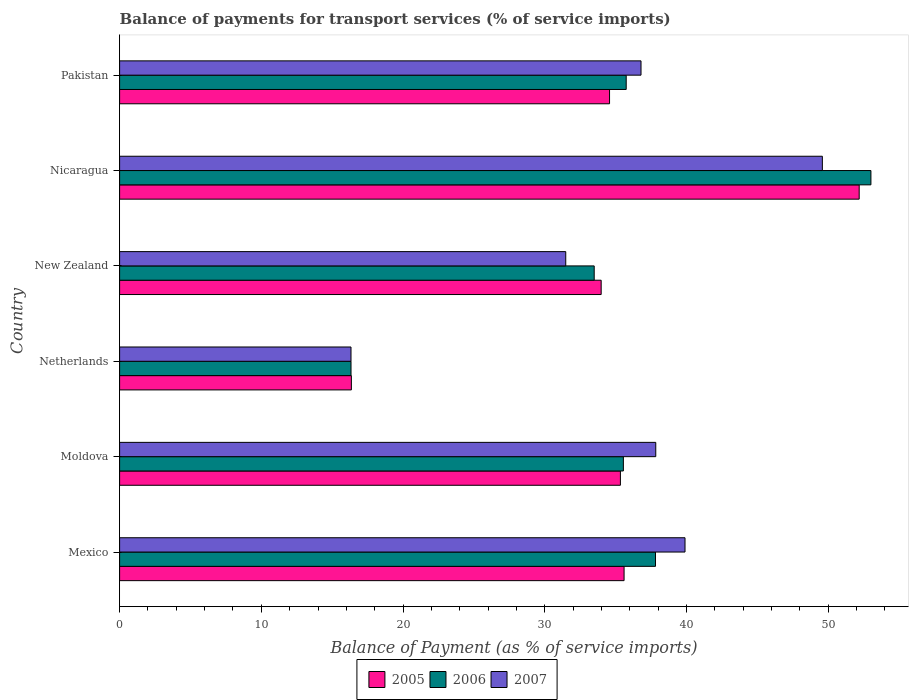Are the number of bars per tick equal to the number of legend labels?
Your answer should be compact. Yes. Are the number of bars on each tick of the Y-axis equal?
Make the answer very short. Yes. How many bars are there on the 4th tick from the top?
Offer a terse response. 3. How many bars are there on the 6th tick from the bottom?
Offer a very short reply. 3. What is the balance of payments for transport services in 2005 in Netherlands?
Your response must be concise. 16.35. Across all countries, what is the maximum balance of payments for transport services in 2005?
Offer a very short reply. 52.19. Across all countries, what is the minimum balance of payments for transport services in 2007?
Your response must be concise. 16.33. In which country was the balance of payments for transport services in 2007 maximum?
Offer a terse response. Nicaragua. In which country was the balance of payments for transport services in 2007 minimum?
Make the answer very short. Netherlands. What is the total balance of payments for transport services in 2005 in the graph?
Offer a very short reply. 208.03. What is the difference between the balance of payments for transport services in 2006 in Nicaragua and that in Pakistan?
Give a very brief answer. 17.27. What is the difference between the balance of payments for transport services in 2005 in New Zealand and the balance of payments for transport services in 2007 in Mexico?
Keep it short and to the point. -5.92. What is the average balance of payments for transport services in 2005 per country?
Give a very brief answer. 34.67. What is the difference between the balance of payments for transport services in 2006 and balance of payments for transport services in 2005 in New Zealand?
Make the answer very short. -0.49. In how many countries, is the balance of payments for transport services in 2005 greater than 20 %?
Provide a short and direct response. 5. What is the ratio of the balance of payments for transport services in 2007 in Nicaragua to that in Pakistan?
Your response must be concise. 1.35. Is the difference between the balance of payments for transport services in 2006 in Moldova and New Zealand greater than the difference between the balance of payments for transport services in 2005 in Moldova and New Zealand?
Make the answer very short. Yes. What is the difference between the highest and the second highest balance of payments for transport services in 2007?
Give a very brief answer. 9.69. What is the difference between the highest and the lowest balance of payments for transport services in 2007?
Ensure brevity in your answer.  33.26. Is the sum of the balance of payments for transport services in 2006 in Mexico and New Zealand greater than the maximum balance of payments for transport services in 2005 across all countries?
Your answer should be very brief. Yes. What does the 3rd bar from the bottom in Netherlands represents?
Keep it short and to the point. 2007. What is the difference between two consecutive major ticks on the X-axis?
Offer a terse response. 10. Are the values on the major ticks of X-axis written in scientific E-notation?
Your answer should be very brief. No. Does the graph contain any zero values?
Your answer should be very brief. No. Does the graph contain grids?
Provide a succinct answer. No. Where does the legend appear in the graph?
Provide a short and direct response. Bottom center. How many legend labels are there?
Give a very brief answer. 3. What is the title of the graph?
Give a very brief answer. Balance of payments for transport services (% of service imports). What is the label or title of the X-axis?
Give a very brief answer. Balance of Payment (as % of service imports). What is the label or title of the Y-axis?
Ensure brevity in your answer.  Country. What is the Balance of Payment (as % of service imports) of 2005 in Mexico?
Make the answer very short. 35.6. What is the Balance of Payment (as % of service imports) of 2006 in Mexico?
Offer a very short reply. 37.81. What is the Balance of Payment (as % of service imports) of 2007 in Mexico?
Offer a terse response. 39.9. What is the Balance of Payment (as % of service imports) of 2005 in Moldova?
Provide a succinct answer. 35.34. What is the Balance of Payment (as % of service imports) in 2006 in Moldova?
Keep it short and to the point. 35.55. What is the Balance of Payment (as % of service imports) of 2007 in Moldova?
Provide a succinct answer. 37.83. What is the Balance of Payment (as % of service imports) in 2005 in Netherlands?
Ensure brevity in your answer.  16.35. What is the Balance of Payment (as % of service imports) of 2006 in Netherlands?
Your answer should be very brief. 16.33. What is the Balance of Payment (as % of service imports) of 2007 in Netherlands?
Provide a short and direct response. 16.33. What is the Balance of Payment (as % of service imports) in 2005 in New Zealand?
Offer a very short reply. 33.98. What is the Balance of Payment (as % of service imports) in 2006 in New Zealand?
Keep it short and to the point. 33.49. What is the Balance of Payment (as % of service imports) of 2007 in New Zealand?
Make the answer very short. 31.48. What is the Balance of Payment (as % of service imports) in 2005 in Nicaragua?
Give a very brief answer. 52.19. What is the Balance of Payment (as % of service imports) of 2006 in Nicaragua?
Make the answer very short. 53.01. What is the Balance of Payment (as % of service imports) in 2007 in Nicaragua?
Your response must be concise. 49.59. What is the Balance of Payment (as % of service imports) in 2005 in Pakistan?
Offer a very short reply. 34.57. What is the Balance of Payment (as % of service imports) of 2006 in Pakistan?
Give a very brief answer. 35.75. What is the Balance of Payment (as % of service imports) in 2007 in Pakistan?
Your answer should be very brief. 36.79. Across all countries, what is the maximum Balance of Payment (as % of service imports) in 2005?
Your response must be concise. 52.19. Across all countries, what is the maximum Balance of Payment (as % of service imports) of 2006?
Your answer should be compact. 53.01. Across all countries, what is the maximum Balance of Payment (as % of service imports) of 2007?
Your answer should be compact. 49.59. Across all countries, what is the minimum Balance of Payment (as % of service imports) of 2005?
Offer a terse response. 16.35. Across all countries, what is the minimum Balance of Payment (as % of service imports) of 2006?
Your response must be concise. 16.33. Across all countries, what is the minimum Balance of Payment (as % of service imports) of 2007?
Keep it short and to the point. 16.33. What is the total Balance of Payment (as % of service imports) of 2005 in the graph?
Give a very brief answer. 208.03. What is the total Balance of Payment (as % of service imports) of 2006 in the graph?
Give a very brief answer. 211.94. What is the total Balance of Payment (as % of service imports) of 2007 in the graph?
Your answer should be very brief. 211.92. What is the difference between the Balance of Payment (as % of service imports) in 2005 in Mexico and that in Moldova?
Provide a succinct answer. 0.26. What is the difference between the Balance of Payment (as % of service imports) in 2006 in Mexico and that in Moldova?
Your response must be concise. 2.27. What is the difference between the Balance of Payment (as % of service imports) of 2007 in Mexico and that in Moldova?
Provide a succinct answer. 2.06. What is the difference between the Balance of Payment (as % of service imports) in 2005 in Mexico and that in Netherlands?
Offer a very short reply. 19.24. What is the difference between the Balance of Payment (as % of service imports) in 2006 in Mexico and that in Netherlands?
Make the answer very short. 21.48. What is the difference between the Balance of Payment (as % of service imports) of 2007 in Mexico and that in Netherlands?
Offer a very short reply. 23.57. What is the difference between the Balance of Payment (as % of service imports) in 2005 in Mexico and that in New Zealand?
Make the answer very short. 1.62. What is the difference between the Balance of Payment (as % of service imports) in 2006 in Mexico and that in New Zealand?
Offer a terse response. 4.33. What is the difference between the Balance of Payment (as % of service imports) in 2007 in Mexico and that in New Zealand?
Your answer should be very brief. 8.42. What is the difference between the Balance of Payment (as % of service imports) of 2005 in Mexico and that in Nicaragua?
Offer a very short reply. -16.59. What is the difference between the Balance of Payment (as % of service imports) in 2006 in Mexico and that in Nicaragua?
Offer a terse response. -15.2. What is the difference between the Balance of Payment (as % of service imports) in 2007 in Mexico and that in Nicaragua?
Provide a succinct answer. -9.69. What is the difference between the Balance of Payment (as % of service imports) in 2005 in Mexico and that in Pakistan?
Your answer should be compact. 1.02. What is the difference between the Balance of Payment (as % of service imports) in 2006 in Mexico and that in Pakistan?
Provide a short and direct response. 2.07. What is the difference between the Balance of Payment (as % of service imports) of 2007 in Mexico and that in Pakistan?
Keep it short and to the point. 3.1. What is the difference between the Balance of Payment (as % of service imports) of 2005 in Moldova and that in Netherlands?
Ensure brevity in your answer.  18.98. What is the difference between the Balance of Payment (as % of service imports) of 2006 in Moldova and that in Netherlands?
Provide a short and direct response. 19.22. What is the difference between the Balance of Payment (as % of service imports) in 2007 in Moldova and that in Netherlands?
Offer a very short reply. 21.51. What is the difference between the Balance of Payment (as % of service imports) in 2005 in Moldova and that in New Zealand?
Offer a very short reply. 1.36. What is the difference between the Balance of Payment (as % of service imports) of 2006 in Moldova and that in New Zealand?
Ensure brevity in your answer.  2.06. What is the difference between the Balance of Payment (as % of service imports) of 2007 in Moldova and that in New Zealand?
Your response must be concise. 6.35. What is the difference between the Balance of Payment (as % of service imports) of 2005 in Moldova and that in Nicaragua?
Ensure brevity in your answer.  -16.85. What is the difference between the Balance of Payment (as % of service imports) in 2006 in Moldova and that in Nicaragua?
Provide a succinct answer. -17.47. What is the difference between the Balance of Payment (as % of service imports) of 2007 in Moldova and that in Nicaragua?
Provide a succinct answer. -11.75. What is the difference between the Balance of Payment (as % of service imports) in 2005 in Moldova and that in Pakistan?
Your response must be concise. 0.77. What is the difference between the Balance of Payment (as % of service imports) in 2006 in Moldova and that in Pakistan?
Your response must be concise. -0.2. What is the difference between the Balance of Payment (as % of service imports) of 2007 in Moldova and that in Pakistan?
Make the answer very short. 1.04. What is the difference between the Balance of Payment (as % of service imports) of 2005 in Netherlands and that in New Zealand?
Provide a succinct answer. -17.63. What is the difference between the Balance of Payment (as % of service imports) of 2006 in Netherlands and that in New Zealand?
Your response must be concise. -17.16. What is the difference between the Balance of Payment (as % of service imports) of 2007 in Netherlands and that in New Zealand?
Offer a terse response. -15.15. What is the difference between the Balance of Payment (as % of service imports) of 2005 in Netherlands and that in Nicaragua?
Ensure brevity in your answer.  -35.83. What is the difference between the Balance of Payment (as % of service imports) of 2006 in Netherlands and that in Nicaragua?
Keep it short and to the point. -36.69. What is the difference between the Balance of Payment (as % of service imports) of 2007 in Netherlands and that in Nicaragua?
Your answer should be very brief. -33.26. What is the difference between the Balance of Payment (as % of service imports) in 2005 in Netherlands and that in Pakistan?
Keep it short and to the point. -18.22. What is the difference between the Balance of Payment (as % of service imports) in 2006 in Netherlands and that in Pakistan?
Provide a succinct answer. -19.42. What is the difference between the Balance of Payment (as % of service imports) of 2007 in Netherlands and that in Pakistan?
Your response must be concise. -20.46. What is the difference between the Balance of Payment (as % of service imports) in 2005 in New Zealand and that in Nicaragua?
Provide a succinct answer. -18.21. What is the difference between the Balance of Payment (as % of service imports) in 2006 in New Zealand and that in Nicaragua?
Your response must be concise. -19.53. What is the difference between the Balance of Payment (as % of service imports) in 2007 in New Zealand and that in Nicaragua?
Ensure brevity in your answer.  -18.11. What is the difference between the Balance of Payment (as % of service imports) of 2005 in New Zealand and that in Pakistan?
Provide a succinct answer. -0.59. What is the difference between the Balance of Payment (as % of service imports) in 2006 in New Zealand and that in Pakistan?
Offer a terse response. -2.26. What is the difference between the Balance of Payment (as % of service imports) in 2007 in New Zealand and that in Pakistan?
Ensure brevity in your answer.  -5.31. What is the difference between the Balance of Payment (as % of service imports) of 2005 in Nicaragua and that in Pakistan?
Make the answer very short. 17.61. What is the difference between the Balance of Payment (as % of service imports) of 2006 in Nicaragua and that in Pakistan?
Your answer should be compact. 17.27. What is the difference between the Balance of Payment (as % of service imports) of 2007 in Nicaragua and that in Pakistan?
Offer a terse response. 12.8. What is the difference between the Balance of Payment (as % of service imports) of 2005 in Mexico and the Balance of Payment (as % of service imports) of 2006 in Moldova?
Your answer should be very brief. 0.05. What is the difference between the Balance of Payment (as % of service imports) in 2005 in Mexico and the Balance of Payment (as % of service imports) in 2007 in Moldova?
Provide a succinct answer. -2.24. What is the difference between the Balance of Payment (as % of service imports) in 2006 in Mexico and the Balance of Payment (as % of service imports) in 2007 in Moldova?
Ensure brevity in your answer.  -0.02. What is the difference between the Balance of Payment (as % of service imports) of 2005 in Mexico and the Balance of Payment (as % of service imports) of 2006 in Netherlands?
Your response must be concise. 19.27. What is the difference between the Balance of Payment (as % of service imports) of 2005 in Mexico and the Balance of Payment (as % of service imports) of 2007 in Netherlands?
Your answer should be compact. 19.27. What is the difference between the Balance of Payment (as % of service imports) of 2006 in Mexico and the Balance of Payment (as % of service imports) of 2007 in Netherlands?
Offer a very short reply. 21.49. What is the difference between the Balance of Payment (as % of service imports) of 2005 in Mexico and the Balance of Payment (as % of service imports) of 2006 in New Zealand?
Your answer should be very brief. 2.11. What is the difference between the Balance of Payment (as % of service imports) in 2005 in Mexico and the Balance of Payment (as % of service imports) in 2007 in New Zealand?
Keep it short and to the point. 4.12. What is the difference between the Balance of Payment (as % of service imports) of 2006 in Mexico and the Balance of Payment (as % of service imports) of 2007 in New Zealand?
Make the answer very short. 6.33. What is the difference between the Balance of Payment (as % of service imports) of 2005 in Mexico and the Balance of Payment (as % of service imports) of 2006 in Nicaragua?
Provide a short and direct response. -17.42. What is the difference between the Balance of Payment (as % of service imports) in 2005 in Mexico and the Balance of Payment (as % of service imports) in 2007 in Nicaragua?
Your answer should be very brief. -13.99. What is the difference between the Balance of Payment (as % of service imports) in 2006 in Mexico and the Balance of Payment (as % of service imports) in 2007 in Nicaragua?
Your response must be concise. -11.77. What is the difference between the Balance of Payment (as % of service imports) of 2005 in Mexico and the Balance of Payment (as % of service imports) of 2006 in Pakistan?
Keep it short and to the point. -0.15. What is the difference between the Balance of Payment (as % of service imports) in 2005 in Mexico and the Balance of Payment (as % of service imports) in 2007 in Pakistan?
Your response must be concise. -1.2. What is the difference between the Balance of Payment (as % of service imports) of 2006 in Mexico and the Balance of Payment (as % of service imports) of 2007 in Pakistan?
Provide a succinct answer. 1.02. What is the difference between the Balance of Payment (as % of service imports) of 2005 in Moldova and the Balance of Payment (as % of service imports) of 2006 in Netherlands?
Ensure brevity in your answer.  19.01. What is the difference between the Balance of Payment (as % of service imports) in 2005 in Moldova and the Balance of Payment (as % of service imports) in 2007 in Netherlands?
Ensure brevity in your answer.  19.01. What is the difference between the Balance of Payment (as % of service imports) of 2006 in Moldova and the Balance of Payment (as % of service imports) of 2007 in Netherlands?
Your answer should be very brief. 19.22. What is the difference between the Balance of Payment (as % of service imports) of 2005 in Moldova and the Balance of Payment (as % of service imports) of 2006 in New Zealand?
Your answer should be compact. 1.85. What is the difference between the Balance of Payment (as % of service imports) of 2005 in Moldova and the Balance of Payment (as % of service imports) of 2007 in New Zealand?
Your response must be concise. 3.86. What is the difference between the Balance of Payment (as % of service imports) in 2006 in Moldova and the Balance of Payment (as % of service imports) in 2007 in New Zealand?
Keep it short and to the point. 4.07. What is the difference between the Balance of Payment (as % of service imports) of 2005 in Moldova and the Balance of Payment (as % of service imports) of 2006 in Nicaragua?
Your answer should be compact. -17.68. What is the difference between the Balance of Payment (as % of service imports) in 2005 in Moldova and the Balance of Payment (as % of service imports) in 2007 in Nicaragua?
Provide a short and direct response. -14.25. What is the difference between the Balance of Payment (as % of service imports) of 2006 in Moldova and the Balance of Payment (as % of service imports) of 2007 in Nicaragua?
Keep it short and to the point. -14.04. What is the difference between the Balance of Payment (as % of service imports) in 2005 in Moldova and the Balance of Payment (as % of service imports) in 2006 in Pakistan?
Give a very brief answer. -0.41. What is the difference between the Balance of Payment (as % of service imports) in 2005 in Moldova and the Balance of Payment (as % of service imports) in 2007 in Pakistan?
Offer a terse response. -1.45. What is the difference between the Balance of Payment (as % of service imports) of 2006 in Moldova and the Balance of Payment (as % of service imports) of 2007 in Pakistan?
Ensure brevity in your answer.  -1.24. What is the difference between the Balance of Payment (as % of service imports) in 2005 in Netherlands and the Balance of Payment (as % of service imports) in 2006 in New Zealand?
Give a very brief answer. -17.13. What is the difference between the Balance of Payment (as % of service imports) of 2005 in Netherlands and the Balance of Payment (as % of service imports) of 2007 in New Zealand?
Provide a short and direct response. -15.13. What is the difference between the Balance of Payment (as % of service imports) in 2006 in Netherlands and the Balance of Payment (as % of service imports) in 2007 in New Zealand?
Your response must be concise. -15.15. What is the difference between the Balance of Payment (as % of service imports) of 2005 in Netherlands and the Balance of Payment (as % of service imports) of 2006 in Nicaragua?
Provide a succinct answer. -36.66. What is the difference between the Balance of Payment (as % of service imports) of 2005 in Netherlands and the Balance of Payment (as % of service imports) of 2007 in Nicaragua?
Provide a succinct answer. -33.23. What is the difference between the Balance of Payment (as % of service imports) of 2006 in Netherlands and the Balance of Payment (as % of service imports) of 2007 in Nicaragua?
Your answer should be very brief. -33.26. What is the difference between the Balance of Payment (as % of service imports) in 2005 in Netherlands and the Balance of Payment (as % of service imports) in 2006 in Pakistan?
Ensure brevity in your answer.  -19.39. What is the difference between the Balance of Payment (as % of service imports) in 2005 in Netherlands and the Balance of Payment (as % of service imports) in 2007 in Pakistan?
Your answer should be very brief. -20.44. What is the difference between the Balance of Payment (as % of service imports) of 2006 in Netherlands and the Balance of Payment (as % of service imports) of 2007 in Pakistan?
Provide a short and direct response. -20.46. What is the difference between the Balance of Payment (as % of service imports) in 2005 in New Zealand and the Balance of Payment (as % of service imports) in 2006 in Nicaragua?
Provide a short and direct response. -19.03. What is the difference between the Balance of Payment (as % of service imports) in 2005 in New Zealand and the Balance of Payment (as % of service imports) in 2007 in Nicaragua?
Offer a very short reply. -15.61. What is the difference between the Balance of Payment (as % of service imports) of 2006 in New Zealand and the Balance of Payment (as % of service imports) of 2007 in Nicaragua?
Your answer should be very brief. -16.1. What is the difference between the Balance of Payment (as % of service imports) of 2005 in New Zealand and the Balance of Payment (as % of service imports) of 2006 in Pakistan?
Make the answer very short. -1.77. What is the difference between the Balance of Payment (as % of service imports) in 2005 in New Zealand and the Balance of Payment (as % of service imports) in 2007 in Pakistan?
Ensure brevity in your answer.  -2.81. What is the difference between the Balance of Payment (as % of service imports) of 2006 in New Zealand and the Balance of Payment (as % of service imports) of 2007 in Pakistan?
Give a very brief answer. -3.3. What is the difference between the Balance of Payment (as % of service imports) of 2005 in Nicaragua and the Balance of Payment (as % of service imports) of 2006 in Pakistan?
Provide a short and direct response. 16.44. What is the difference between the Balance of Payment (as % of service imports) of 2005 in Nicaragua and the Balance of Payment (as % of service imports) of 2007 in Pakistan?
Ensure brevity in your answer.  15.39. What is the difference between the Balance of Payment (as % of service imports) of 2006 in Nicaragua and the Balance of Payment (as % of service imports) of 2007 in Pakistan?
Your response must be concise. 16.22. What is the average Balance of Payment (as % of service imports) in 2005 per country?
Keep it short and to the point. 34.67. What is the average Balance of Payment (as % of service imports) in 2006 per country?
Make the answer very short. 35.32. What is the average Balance of Payment (as % of service imports) in 2007 per country?
Provide a succinct answer. 35.32. What is the difference between the Balance of Payment (as % of service imports) of 2005 and Balance of Payment (as % of service imports) of 2006 in Mexico?
Your answer should be very brief. -2.22. What is the difference between the Balance of Payment (as % of service imports) of 2005 and Balance of Payment (as % of service imports) of 2007 in Mexico?
Your answer should be compact. -4.3. What is the difference between the Balance of Payment (as % of service imports) in 2006 and Balance of Payment (as % of service imports) in 2007 in Mexico?
Offer a terse response. -2.08. What is the difference between the Balance of Payment (as % of service imports) of 2005 and Balance of Payment (as % of service imports) of 2006 in Moldova?
Your response must be concise. -0.21. What is the difference between the Balance of Payment (as % of service imports) in 2005 and Balance of Payment (as % of service imports) in 2007 in Moldova?
Keep it short and to the point. -2.49. What is the difference between the Balance of Payment (as % of service imports) of 2006 and Balance of Payment (as % of service imports) of 2007 in Moldova?
Offer a very short reply. -2.29. What is the difference between the Balance of Payment (as % of service imports) of 2005 and Balance of Payment (as % of service imports) of 2006 in Netherlands?
Offer a terse response. 0.03. What is the difference between the Balance of Payment (as % of service imports) of 2005 and Balance of Payment (as % of service imports) of 2007 in Netherlands?
Offer a very short reply. 0.03. What is the difference between the Balance of Payment (as % of service imports) of 2006 and Balance of Payment (as % of service imports) of 2007 in Netherlands?
Ensure brevity in your answer.  0. What is the difference between the Balance of Payment (as % of service imports) of 2005 and Balance of Payment (as % of service imports) of 2006 in New Zealand?
Offer a very short reply. 0.49. What is the difference between the Balance of Payment (as % of service imports) of 2005 and Balance of Payment (as % of service imports) of 2007 in New Zealand?
Ensure brevity in your answer.  2.5. What is the difference between the Balance of Payment (as % of service imports) of 2006 and Balance of Payment (as % of service imports) of 2007 in New Zealand?
Make the answer very short. 2.01. What is the difference between the Balance of Payment (as % of service imports) of 2005 and Balance of Payment (as % of service imports) of 2006 in Nicaragua?
Provide a short and direct response. -0.83. What is the difference between the Balance of Payment (as % of service imports) of 2005 and Balance of Payment (as % of service imports) of 2007 in Nicaragua?
Make the answer very short. 2.6. What is the difference between the Balance of Payment (as % of service imports) of 2006 and Balance of Payment (as % of service imports) of 2007 in Nicaragua?
Your answer should be compact. 3.43. What is the difference between the Balance of Payment (as % of service imports) of 2005 and Balance of Payment (as % of service imports) of 2006 in Pakistan?
Ensure brevity in your answer.  -1.17. What is the difference between the Balance of Payment (as % of service imports) of 2005 and Balance of Payment (as % of service imports) of 2007 in Pakistan?
Ensure brevity in your answer.  -2.22. What is the difference between the Balance of Payment (as % of service imports) in 2006 and Balance of Payment (as % of service imports) in 2007 in Pakistan?
Offer a very short reply. -1.04. What is the ratio of the Balance of Payment (as % of service imports) in 2005 in Mexico to that in Moldova?
Your answer should be compact. 1.01. What is the ratio of the Balance of Payment (as % of service imports) of 2006 in Mexico to that in Moldova?
Ensure brevity in your answer.  1.06. What is the ratio of the Balance of Payment (as % of service imports) in 2007 in Mexico to that in Moldova?
Your response must be concise. 1.05. What is the ratio of the Balance of Payment (as % of service imports) in 2005 in Mexico to that in Netherlands?
Offer a very short reply. 2.18. What is the ratio of the Balance of Payment (as % of service imports) in 2006 in Mexico to that in Netherlands?
Your response must be concise. 2.32. What is the ratio of the Balance of Payment (as % of service imports) of 2007 in Mexico to that in Netherlands?
Offer a very short reply. 2.44. What is the ratio of the Balance of Payment (as % of service imports) in 2005 in Mexico to that in New Zealand?
Your answer should be very brief. 1.05. What is the ratio of the Balance of Payment (as % of service imports) in 2006 in Mexico to that in New Zealand?
Your answer should be very brief. 1.13. What is the ratio of the Balance of Payment (as % of service imports) in 2007 in Mexico to that in New Zealand?
Your answer should be compact. 1.27. What is the ratio of the Balance of Payment (as % of service imports) of 2005 in Mexico to that in Nicaragua?
Provide a succinct answer. 0.68. What is the ratio of the Balance of Payment (as % of service imports) of 2006 in Mexico to that in Nicaragua?
Keep it short and to the point. 0.71. What is the ratio of the Balance of Payment (as % of service imports) of 2007 in Mexico to that in Nicaragua?
Offer a very short reply. 0.8. What is the ratio of the Balance of Payment (as % of service imports) in 2005 in Mexico to that in Pakistan?
Provide a short and direct response. 1.03. What is the ratio of the Balance of Payment (as % of service imports) in 2006 in Mexico to that in Pakistan?
Keep it short and to the point. 1.06. What is the ratio of the Balance of Payment (as % of service imports) of 2007 in Mexico to that in Pakistan?
Offer a terse response. 1.08. What is the ratio of the Balance of Payment (as % of service imports) in 2005 in Moldova to that in Netherlands?
Offer a very short reply. 2.16. What is the ratio of the Balance of Payment (as % of service imports) in 2006 in Moldova to that in Netherlands?
Provide a short and direct response. 2.18. What is the ratio of the Balance of Payment (as % of service imports) in 2007 in Moldova to that in Netherlands?
Offer a very short reply. 2.32. What is the ratio of the Balance of Payment (as % of service imports) in 2006 in Moldova to that in New Zealand?
Give a very brief answer. 1.06. What is the ratio of the Balance of Payment (as % of service imports) of 2007 in Moldova to that in New Zealand?
Ensure brevity in your answer.  1.2. What is the ratio of the Balance of Payment (as % of service imports) of 2005 in Moldova to that in Nicaragua?
Provide a succinct answer. 0.68. What is the ratio of the Balance of Payment (as % of service imports) of 2006 in Moldova to that in Nicaragua?
Offer a very short reply. 0.67. What is the ratio of the Balance of Payment (as % of service imports) in 2007 in Moldova to that in Nicaragua?
Offer a terse response. 0.76. What is the ratio of the Balance of Payment (as % of service imports) in 2005 in Moldova to that in Pakistan?
Make the answer very short. 1.02. What is the ratio of the Balance of Payment (as % of service imports) of 2006 in Moldova to that in Pakistan?
Make the answer very short. 0.99. What is the ratio of the Balance of Payment (as % of service imports) in 2007 in Moldova to that in Pakistan?
Your answer should be very brief. 1.03. What is the ratio of the Balance of Payment (as % of service imports) in 2005 in Netherlands to that in New Zealand?
Your answer should be compact. 0.48. What is the ratio of the Balance of Payment (as % of service imports) in 2006 in Netherlands to that in New Zealand?
Provide a succinct answer. 0.49. What is the ratio of the Balance of Payment (as % of service imports) of 2007 in Netherlands to that in New Zealand?
Provide a short and direct response. 0.52. What is the ratio of the Balance of Payment (as % of service imports) of 2005 in Netherlands to that in Nicaragua?
Keep it short and to the point. 0.31. What is the ratio of the Balance of Payment (as % of service imports) of 2006 in Netherlands to that in Nicaragua?
Offer a very short reply. 0.31. What is the ratio of the Balance of Payment (as % of service imports) in 2007 in Netherlands to that in Nicaragua?
Your answer should be very brief. 0.33. What is the ratio of the Balance of Payment (as % of service imports) of 2005 in Netherlands to that in Pakistan?
Offer a terse response. 0.47. What is the ratio of the Balance of Payment (as % of service imports) in 2006 in Netherlands to that in Pakistan?
Your answer should be very brief. 0.46. What is the ratio of the Balance of Payment (as % of service imports) of 2007 in Netherlands to that in Pakistan?
Keep it short and to the point. 0.44. What is the ratio of the Balance of Payment (as % of service imports) of 2005 in New Zealand to that in Nicaragua?
Offer a terse response. 0.65. What is the ratio of the Balance of Payment (as % of service imports) of 2006 in New Zealand to that in Nicaragua?
Keep it short and to the point. 0.63. What is the ratio of the Balance of Payment (as % of service imports) of 2007 in New Zealand to that in Nicaragua?
Offer a very short reply. 0.63. What is the ratio of the Balance of Payment (as % of service imports) of 2005 in New Zealand to that in Pakistan?
Offer a very short reply. 0.98. What is the ratio of the Balance of Payment (as % of service imports) of 2006 in New Zealand to that in Pakistan?
Offer a terse response. 0.94. What is the ratio of the Balance of Payment (as % of service imports) of 2007 in New Zealand to that in Pakistan?
Provide a short and direct response. 0.86. What is the ratio of the Balance of Payment (as % of service imports) in 2005 in Nicaragua to that in Pakistan?
Ensure brevity in your answer.  1.51. What is the ratio of the Balance of Payment (as % of service imports) of 2006 in Nicaragua to that in Pakistan?
Provide a succinct answer. 1.48. What is the ratio of the Balance of Payment (as % of service imports) in 2007 in Nicaragua to that in Pakistan?
Your response must be concise. 1.35. What is the difference between the highest and the second highest Balance of Payment (as % of service imports) of 2005?
Your answer should be very brief. 16.59. What is the difference between the highest and the second highest Balance of Payment (as % of service imports) in 2006?
Your answer should be compact. 15.2. What is the difference between the highest and the second highest Balance of Payment (as % of service imports) in 2007?
Your answer should be compact. 9.69. What is the difference between the highest and the lowest Balance of Payment (as % of service imports) of 2005?
Ensure brevity in your answer.  35.83. What is the difference between the highest and the lowest Balance of Payment (as % of service imports) in 2006?
Your answer should be compact. 36.69. What is the difference between the highest and the lowest Balance of Payment (as % of service imports) in 2007?
Your answer should be very brief. 33.26. 